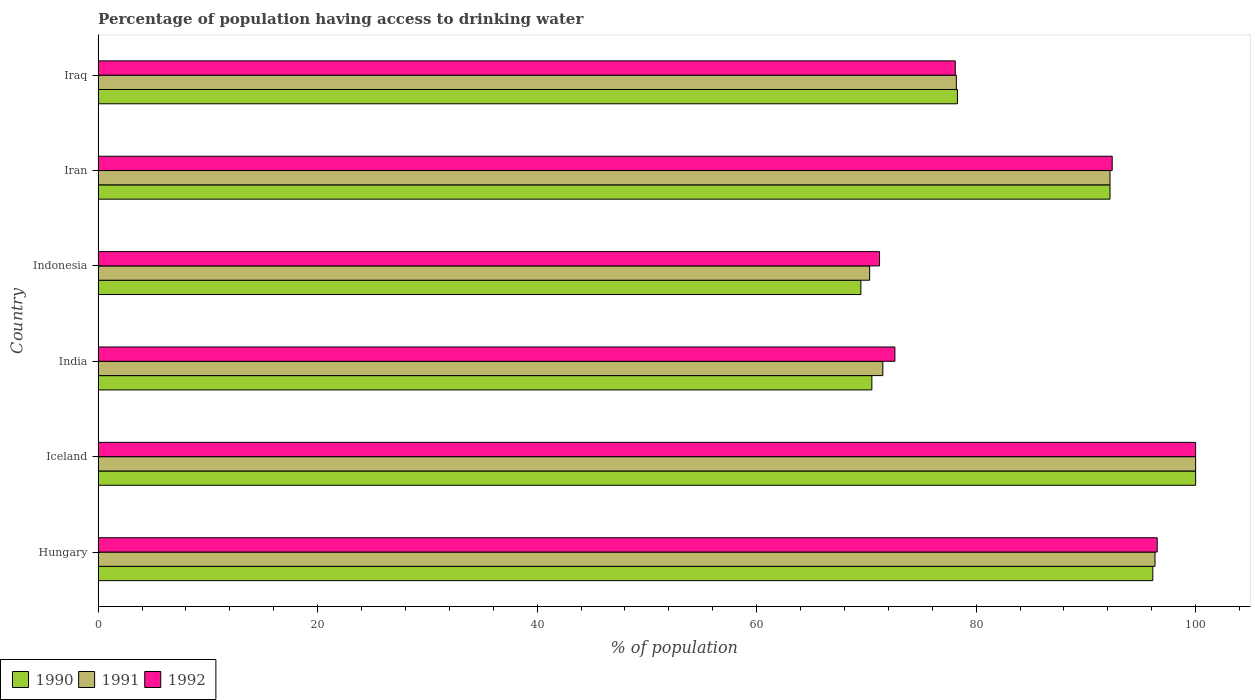How many groups of bars are there?
Your response must be concise. 6. Are the number of bars per tick equal to the number of legend labels?
Your answer should be very brief. Yes. How many bars are there on the 6th tick from the top?
Offer a terse response. 3. In how many cases, is the number of bars for a given country not equal to the number of legend labels?
Make the answer very short. 0. Across all countries, what is the minimum percentage of population having access to drinking water in 1992?
Your answer should be very brief. 71.2. In which country was the percentage of population having access to drinking water in 1992 maximum?
Provide a succinct answer. Iceland. In which country was the percentage of population having access to drinking water in 1992 minimum?
Provide a short and direct response. Indonesia. What is the total percentage of population having access to drinking water in 1991 in the graph?
Offer a terse response. 508.5. What is the difference between the percentage of population having access to drinking water in 1990 in India and the percentage of population having access to drinking water in 1991 in Iran?
Offer a very short reply. -21.7. What is the average percentage of population having access to drinking water in 1991 per country?
Your answer should be very brief. 84.75. What is the difference between the percentage of population having access to drinking water in 1990 and percentage of population having access to drinking water in 1992 in Iran?
Offer a very short reply. -0.2. In how many countries, is the percentage of population having access to drinking water in 1992 greater than 72 %?
Provide a short and direct response. 5. What is the ratio of the percentage of population having access to drinking water in 1992 in Indonesia to that in Iraq?
Offer a terse response. 0.91. Is the percentage of population having access to drinking water in 1990 in Iceland less than that in Iraq?
Provide a succinct answer. No. What is the difference between the highest and the second highest percentage of population having access to drinking water in 1992?
Keep it short and to the point. 3.5. What is the difference between the highest and the lowest percentage of population having access to drinking water in 1992?
Ensure brevity in your answer.  28.8. What does the 1st bar from the top in Iran represents?
Your answer should be very brief. 1992. Is it the case that in every country, the sum of the percentage of population having access to drinking water in 1992 and percentage of population having access to drinking water in 1991 is greater than the percentage of population having access to drinking water in 1990?
Your answer should be compact. Yes. How many bars are there?
Provide a short and direct response. 18. How many countries are there in the graph?
Keep it short and to the point. 6. What is the difference between two consecutive major ticks on the X-axis?
Provide a succinct answer. 20. Are the values on the major ticks of X-axis written in scientific E-notation?
Give a very brief answer. No. Does the graph contain grids?
Provide a short and direct response. No. Where does the legend appear in the graph?
Offer a very short reply. Bottom left. How are the legend labels stacked?
Your answer should be very brief. Horizontal. What is the title of the graph?
Offer a terse response. Percentage of population having access to drinking water. Does "1978" appear as one of the legend labels in the graph?
Offer a very short reply. No. What is the label or title of the X-axis?
Your response must be concise. % of population. What is the label or title of the Y-axis?
Your answer should be very brief. Country. What is the % of population of 1990 in Hungary?
Ensure brevity in your answer.  96.1. What is the % of population of 1991 in Hungary?
Your answer should be very brief. 96.3. What is the % of population in 1992 in Hungary?
Your answer should be compact. 96.5. What is the % of population of 1991 in Iceland?
Make the answer very short. 100. What is the % of population in 1992 in Iceland?
Ensure brevity in your answer.  100. What is the % of population in 1990 in India?
Provide a succinct answer. 70.5. What is the % of population in 1991 in India?
Offer a very short reply. 71.5. What is the % of population in 1992 in India?
Your response must be concise. 72.6. What is the % of population of 1990 in Indonesia?
Your answer should be compact. 69.5. What is the % of population of 1991 in Indonesia?
Provide a succinct answer. 70.3. What is the % of population of 1992 in Indonesia?
Your answer should be compact. 71.2. What is the % of population in 1990 in Iran?
Make the answer very short. 92.2. What is the % of population in 1991 in Iran?
Provide a short and direct response. 92.2. What is the % of population in 1992 in Iran?
Offer a terse response. 92.4. What is the % of population of 1990 in Iraq?
Offer a terse response. 78.3. What is the % of population of 1991 in Iraq?
Offer a very short reply. 78.2. What is the % of population in 1992 in Iraq?
Your answer should be very brief. 78.1. Across all countries, what is the maximum % of population of 1992?
Provide a succinct answer. 100. Across all countries, what is the minimum % of population of 1990?
Provide a succinct answer. 69.5. Across all countries, what is the minimum % of population of 1991?
Your response must be concise. 70.3. Across all countries, what is the minimum % of population of 1992?
Keep it short and to the point. 71.2. What is the total % of population of 1990 in the graph?
Keep it short and to the point. 506.6. What is the total % of population in 1991 in the graph?
Your response must be concise. 508.5. What is the total % of population in 1992 in the graph?
Keep it short and to the point. 510.8. What is the difference between the % of population in 1990 in Hungary and that in Iceland?
Your response must be concise. -3.9. What is the difference between the % of population of 1992 in Hungary and that in Iceland?
Ensure brevity in your answer.  -3.5. What is the difference between the % of population of 1990 in Hungary and that in India?
Your answer should be very brief. 25.6. What is the difference between the % of population in 1991 in Hungary and that in India?
Ensure brevity in your answer.  24.8. What is the difference between the % of population of 1992 in Hungary and that in India?
Offer a very short reply. 23.9. What is the difference between the % of population of 1990 in Hungary and that in Indonesia?
Offer a very short reply. 26.6. What is the difference between the % of population of 1992 in Hungary and that in Indonesia?
Ensure brevity in your answer.  25.3. What is the difference between the % of population of 1990 in Hungary and that in Iran?
Keep it short and to the point. 3.9. What is the difference between the % of population in 1992 in Hungary and that in Iran?
Provide a short and direct response. 4.1. What is the difference between the % of population in 1990 in Hungary and that in Iraq?
Your answer should be very brief. 17.8. What is the difference between the % of population of 1992 in Hungary and that in Iraq?
Offer a very short reply. 18.4. What is the difference between the % of population of 1990 in Iceland and that in India?
Your answer should be compact. 29.5. What is the difference between the % of population of 1992 in Iceland and that in India?
Your answer should be compact. 27.4. What is the difference between the % of population in 1990 in Iceland and that in Indonesia?
Your answer should be compact. 30.5. What is the difference between the % of population of 1991 in Iceland and that in Indonesia?
Your answer should be very brief. 29.7. What is the difference between the % of population in 1992 in Iceland and that in Indonesia?
Make the answer very short. 28.8. What is the difference between the % of population of 1990 in Iceland and that in Iran?
Offer a very short reply. 7.8. What is the difference between the % of population in 1991 in Iceland and that in Iran?
Offer a very short reply. 7.8. What is the difference between the % of population in 1992 in Iceland and that in Iran?
Ensure brevity in your answer.  7.6. What is the difference between the % of population of 1990 in Iceland and that in Iraq?
Your answer should be very brief. 21.7. What is the difference between the % of population of 1991 in Iceland and that in Iraq?
Offer a very short reply. 21.8. What is the difference between the % of population of 1992 in Iceland and that in Iraq?
Provide a short and direct response. 21.9. What is the difference between the % of population of 1991 in India and that in Indonesia?
Your answer should be very brief. 1.2. What is the difference between the % of population in 1990 in India and that in Iran?
Your answer should be compact. -21.7. What is the difference between the % of population in 1991 in India and that in Iran?
Provide a succinct answer. -20.7. What is the difference between the % of population of 1992 in India and that in Iran?
Provide a succinct answer. -19.8. What is the difference between the % of population in 1991 in India and that in Iraq?
Make the answer very short. -6.7. What is the difference between the % of population of 1990 in Indonesia and that in Iran?
Your answer should be very brief. -22.7. What is the difference between the % of population of 1991 in Indonesia and that in Iran?
Provide a short and direct response. -21.9. What is the difference between the % of population of 1992 in Indonesia and that in Iran?
Keep it short and to the point. -21.2. What is the difference between the % of population in 1990 in Indonesia and that in Iraq?
Your response must be concise. -8.8. What is the difference between the % of population in 1992 in Indonesia and that in Iraq?
Keep it short and to the point. -6.9. What is the difference between the % of population of 1990 in Hungary and the % of population of 1991 in Iceland?
Ensure brevity in your answer.  -3.9. What is the difference between the % of population in 1991 in Hungary and the % of population in 1992 in Iceland?
Keep it short and to the point. -3.7. What is the difference between the % of population in 1990 in Hungary and the % of population in 1991 in India?
Make the answer very short. 24.6. What is the difference between the % of population of 1991 in Hungary and the % of population of 1992 in India?
Your response must be concise. 23.7. What is the difference between the % of population of 1990 in Hungary and the % of population of 1991 in Indonesia?
Your response must be concise. 25.8. What is the difference between the % of population in 1990 in Hungary and the % of population in 1992 in Indonesia?
Give a very brief answer. 24.9. What is the difference between the % of population of 1991 in Hungary and the % of population of 1992 in Indonesia?
Your answer should be compact. 25.1. What is the difference between the % of population of 1990 in Hungary and the % of population of 1992 in Iran?
Your answer should be very brief. 3.7. What is the difference between the % of population in 1991 in Hungary and the % of population in 1992 in Iran?
Keep it short and to the point. 3.9. What is the difference between the % of population in 1990 in Hungary and the % of population in 1992 in Iraq?
Offer a very short reply. 18. What is the difference between the % of population of 1991 in Hungary and the % of population of 1992 in Iraq?
Offer a very short reply. 18.2. What is the difference between the % of population in 1990 in Iceland and the % of population in 1991 in India?
Offer a terse response. 28.5. What is the difference between the % of population in 1990 in Iceland and the % of population in 1992 in India?
Offer a terse response. 27.4. What is the difference between the % of population in 1991 in Iceland and the % of population in 1992 in India?
Provide a succinct answer. 27.4. What is the difference between the % of population in 1990 in Iceland and the % of population in 1991 in Indonesia?
Ensure brevity in your answer.  29.7. What is the difference between the % of population of 1990 in Iceland and the % of population of 1992 in Indonesia?
Ensure brevity in your answer.  28.8. What is the difference between the % of population of 1991 in Iceland and the % of population of 1992 in Indonesia?
Keep it short and to the point. 28.8. What is the difference between the % of population of 1990 in Iceland and the % of population of 1991 in Iraq?
Offer a terse response. 21.8. What is the difference between the % of population of 1990 in Iceland and the % of population of 1992 in Iraq?
Keep it short and to the point. 21.9. What is the difference between the % of population in 1991 in Iceland and the % of population in 1992 in Iraq?
Provide a short and direct response. 21.9. What is the difference between the % of population in 1990 in India and the % of population in 1991 in Iran?
Your answer should be compact. -21.7. What is the difference between the % of population in 1990 in India and the % of population in 1992 in Iran?
Ensure brevity in your answer.  -21.9. What is the difference between the % of population in 1991 in India and the % of population in 1992 in Iran?
Give a very brief answer. -20.9. What is the difference between the % of population in 1990 in India and the % of population in 1992 in Iraq?
Your answer should be very brief. -7.6. What is the difference between the % of population in 1990 in Indonesia and the % of population in 1991 in Iran?
Provide a succinct answer. -22.7. What is the difference between the % of population of 1990 in Indonesia and the % of population of 1992 in Iran?
Offer a terse response. -22.9. What is the difference between the % of population of 1991 in Indonesia and the % of population of 1992 in Iran?
Offer a terse response. -22.1. What is the difference between the % of population in 1990 in Indonesia and the % of population in 1992 in Iraq?
Offer a terse response. -8.6. What is the difference between the % of population of 1991 in Indonesia and the % of population of 1992 in Iraq?
Provide a short and direct response. -7.8. What is the difference between the % of population of 1990 in Iran and the % of population of 1991 in Iraq?
Ensure brevity in your answer.  14. What is the difference between the % of population in 1990 in Iran and the % of population in 1992 in Iraq?
Give a very brief answer. 14.1. What is the difference between the % of population in 1991 in Iran and the % of population in 1992 in Iraq?
Make the answer very short. 14.1. What is the average % of population of 1990 per country?
Ensure brevity in your answer.  84.43. What is the average % of population in 1991 per country?
Offer a terse response. 84.75. What is the average % of population in 1992 per country?
Give a very brief answer. 85.13. What is the difference between the % of population of 1990 and % of population of 1992 in Hungary?
Your answer should be compact. -0.4. What is the difference between the % of population in 1991 and % of population in 1992 in Hungary?
Make the answer very short. -0.2. What is the difference between the % of population in 1990 and % of population in 1992 in India?
Your answer should be very brief. -2.1. What is the difference between the % of population in 1991 and % of population in 1992 in India?
Provide a succinct answer. -1.1. What is the difference between the % of population of 1990 and % of population of 1992 in Indonesia?
Your answer should be very brief. -1.7. What is the difference between the % of population of 1990 and % of population of 1991 in Iran?
Your answer should be compact. 0. What is the difference between the % of population in 1991 and % of population in 1992 in Iran?
Ensure brevity in your answer.  -0.2. What is the ratio of the % of population in 1990 in Hungary to that in Iceland?
Keep it short and to the point. 0.96. What is the ratio of the % of population of 1991 in Hungary to that in Iceland?
Ensure brevity in your answer.  0.96. What is the ratio of the % of population of 1990 in Hungary to that in India?
Your answer should be compact. 1.36. What is the ratio of the % of population of 1991 in Hungary to that in India?
Your answer should be compact. 1.35. What is the ratio of the % of population of 1992 in Hungary to that in India?
Your answer should be very brief. 1.33. What is the ratio of the % of population of 1990 in Hungary to that in Indonesia?
Your answer should be compact. 1.38. What is the ratio of the % of population of 1991 in Hungary to that in Indonesia?
Provide a short and direct response. 1.37. What is the ratio of the % of population of 1992 in Hungary to that in Indonesia?
Your response must be concise. 1.36. What is the ratio of the % of population of 1990 in Hungary to that in Iran?
Keep it short and to the point. 1.04. What is the ratio of the % of population of 1991 in Hungary to that in Iran?
Make the answer very short. 1.04. What is the ratio of the % of population in 1992 in Hungary to that in Iran?
Provide a short and direct response. 1.04. What is the ratio of the % of population of 1990 in Hungary to that in Iraq?
Offer a very short reply. 1.23. What is the ratio of the % of population in 1991 in Hungary to that in Iraq?
Offer a terse response. 1.23. What is the ratio of the % of population of 1992 in Hungary to that in Iraq?
Offer a terse response. 1.24. What is the ratio of the % of population in 1990 in Iceland to that in India?
Keep it short and to the point. 1.42. What is the ratio of the % of population of 1991 in Iceland to that in India?
Offer a terse response. 1.4. What is the ratio of the % of population of 1992 in Iceland to that in India?
Provide a succinct answer. 1.38. What is the ratio of the % of population in 1990 in Iceland to that in Indonesia?
Your answer should be very brief. 1.44. What is the ratio of the % of population in 1991 in Iceland to that in Indonesia?
Offer a terse response. 1.42. What is the ratio of the % of population in 1992 in Iceland to that in Indonesia?
Your answer should be very brief. 1.4. What is the ratio of the % of population of 1990 in Iceland to that in Iran?
Provide a succinct answer. 1.08. What is the ratio of the % of population in 1991 in Iceland to that in Iran?
Your answer should be compact. 1.08. What is the ratio of the % of population of 1992 in Iceland to that in Iran?
Make the answer very short. 1.08. What is the ratio of the % of population of 1990 in Iceland to that in Iraq?
Your answer should be compact. 1.28. What is the ratio of the % of population in 1991 in Iceland to that in Iraq?
Provide a short and direct response. 1.28. What is the ratio of the % of population in 1992 in Iceland to that in Iraq?
Keep it short and to the point. 1.28. What is the ratio of the % of population of 1990 in India to that in Indonesia?
Make the answer very short. 1.01. What is the ratio of the % of population of 1991 in India to that in Indonesia?
Your answer should be compact. 1.02. What is the ratio of the % of population of 1992 in India to that in Indonesia?
Give a very brief answer. 1.02. What is the ratio of the % of population in 1990 in India to that in Iran?
Your response must be concise. 0.76. What is the ratio of the % of population in 1991 in India to that in Iran?
Your answer should be very brief. 0.78. What is the ratio of the % of population of 1992 in India to that in Iran?
Keep it short and to the point. 0.79. What is the ratio of the % of population of 1990 in India to that in Iraq?
Your answer should be compact. 0.9. What is the ratio of the % of population in 1991 in India to that in Iraq?
Provide a succinct answer. 0.91. What is the ratio of the % of population in 1992 in India to that in Iraq?
Offer a very short reply. 0.93. What is the ratio of the % of population of 1990 in Indonesia to that in Iran?
Offer a very short reply. 0.75. What is the ratio of the % of population in 1991 in Indonesia to that in Iran?
Keep it short and to the point. 0.76. What is the ratio of the % of population of 1992 in Indonesia to that in Iran?
Make the answer very short. 0.77. What is the ratio of the % of population of 1990 in Indonesia to that in Iraq?
Provide a short and direct response. 0.89. What is the ratio of the % of population of 1991 in Indonesia to that in Iraq?
Offer a terse response. 0.9. What is the ratio of the % of population in 1992 in Indonesia to that in Iraq?
Provide a short and direct response. 0.91. What is the ratio of the % of population of 1990 in Iran to that in Iraq?
Offer a very short reply. 1.18. What is the ratio of the % of population of 1991 in Iran to that in Iraq?
Your answer should be compact. 1.18. What is the ratio of the % of population of 1992 in Iran to that in Iraq?
Provide a succinct answer. 1.18. What is the difference between the highest and the lowest % of population of 1990?
Make the answer very short. 30.5. What is the difference between the highest and the lowest % of population of 1991?
Your response must be concise. 29.7. What is the difference between the highest and the lowest % of population of 1992?
Ensure brevity in your answer.  28.8. 